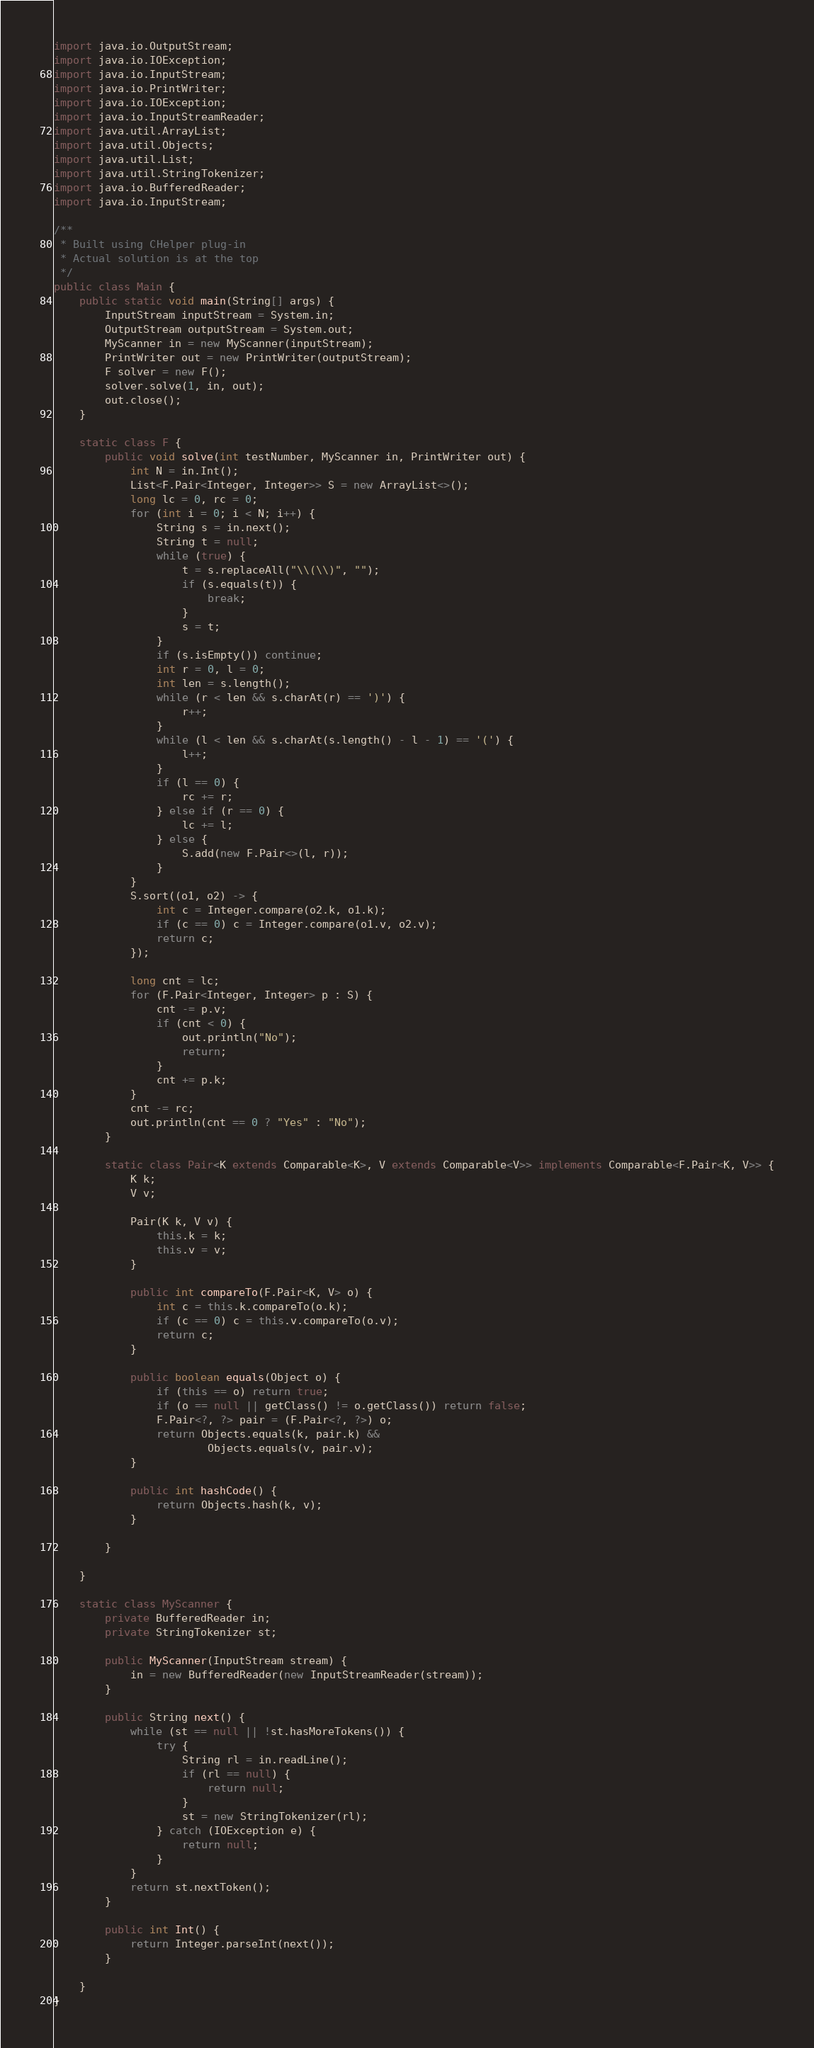<code> <loc_0><loc_0><loc_500><loc_500><_Java_>import java.io.OutputStream;
import java.io.IOException;
import java.io.InputStream;
import java.io.PrintWriter;
import java.io.IOException;
import java.io.InputStreamReader;
import java.util.ArrayList;
import java.util.Objects;
import java.util.List;
import java.util.StringTokenizer;
import java.io.BufferedReader;
import java.io.InputStream;

/**
 * Built using CHelper plug-in
 * Actual solution is at the top
 */
public class Main {
    public static void main(String[] args) {
        InputStream inputStream = System.in;
        OutputStream outputStream = System.out;
        MyScanner in = new MyScanner(inputStream);
        PrintWriter out = new PrintWriter(outputStream);
        F solver = new F();
        solver.solve(1, in, out);
        out.close();
    }

    static class F {
        public void solve(int testNumber, MyScanner in, PrintWriter out) {
            int N = in.Int();
            List<F.Pair<Integer, Integer>> S = new ArrayList<>();
            long lc = 0, rc = 0;
            for (int i = 0; i < N; i++) {
                String s = in.next();
                String t = null;
                while (true) {
                    t = s.replaceAll("\\(\\)", "");
                    if (s.equals(t)) {
                        break;
                    }
                    s = t;
                }
                if (s.isEmpty()) continue;
                int r = 0, l = 0;
                int len = s.length();
                while (r < len && s.charAt(r) == ')') {
                    r++;
                }
                while (l < len && s.charAt(s.length() - l - 1) == '(') {
                    l++;
                }
                if (l == 0) {
                    rc += r;
                } else if (r == 0) {
                    lc += l;
                } else {
                    S.add(new F.Pair<>(l, r));
                }
            }
            S.sort((o1, o2) -> {
                int c = Integer.compare(o2.k, o1.k);
                if (c == 0) c = Integer.compare(o1.v, o2.v);
                return c;
            });

            long cnt = lc;
            for (F.Pair<Integer, Integer> p : S) {
                cnt -= p.v;
                if (cnt < 0) {
                    out.println("No");
                    return;
                }
                cnt += p.k;
            }
            cnt -= rc;
            out.println(cnt == 0 ? "Yes" : "No");
        }

        static class Pair<K extends Comparable<K>, V extends Comparable<V>> implements Comparable<F.Pair<K, V>> {
            K k;
            V v;

            Pair(K k, V v) {
                this.k = k;
                this.v = v;
            }

            public int compareTo(F.Pair<K, V> o) {
                int c = this.k.compareTo(o.k);
                if (c == 0) c = this.v.compareTo(o.v);
                return c;
            }

            public boolean equals(Object o) {
                if (this == o) return true;
                if (o == null || getClass() != o.getClass()) return false;
                F.Pair<?, ?> pair = (F.Pair<?, ?>) o;
                return Objects.equals(k, pair.k) &&
                        Objects.equals(v, pair.v);
            }

            public int hashCode() {
                return Objects.hash(k, v);
            }

        }

    }

    static class MyScanner {
        private BufferedReader in;
        private StringTokenizer st;

        public MyScanner(InputStream stream) {
            in = new BufferedReader(new InputStreamReader(stream));
        }

        public String next() {
            while (st == null || !st.hasMoreTokens()) {
                try {
                    String rl = in.readLine();
                    if (rl == null) {
                        return null;
                    }
                    st = new StringTokenizer(rl);
                } catch (IOException e) {
                    return null;
                }
            }
            return st.nextToken();
        }

        public int Int() {
            return Integer.parseInt(next());
        }

    }
}

</code> 